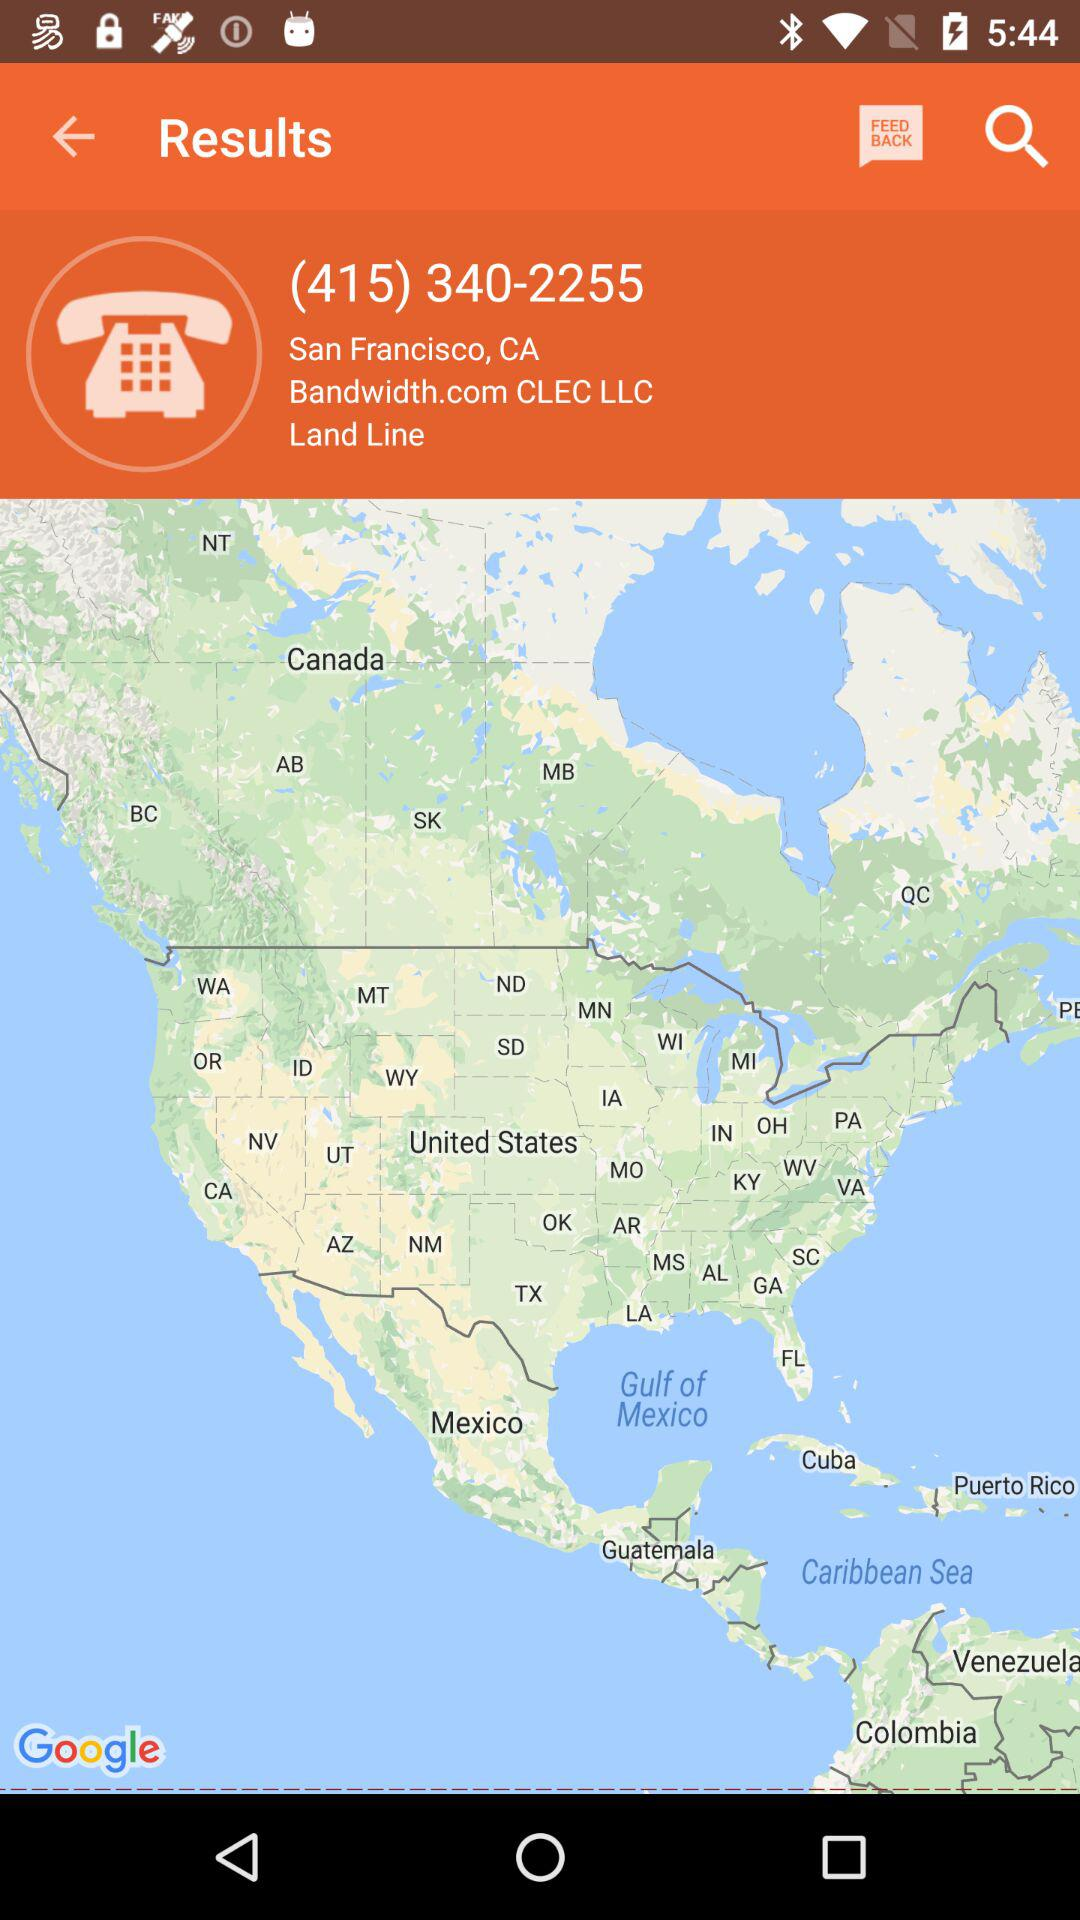What is the phone number? The phone number is (415) 340-2255. 